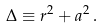Convert formula to latex. <formula><loc_0><loc_0><loc_500><loc_500>\Delta \equiv r ^ { 2 } + a ^ { 2 } \, .</formula> 